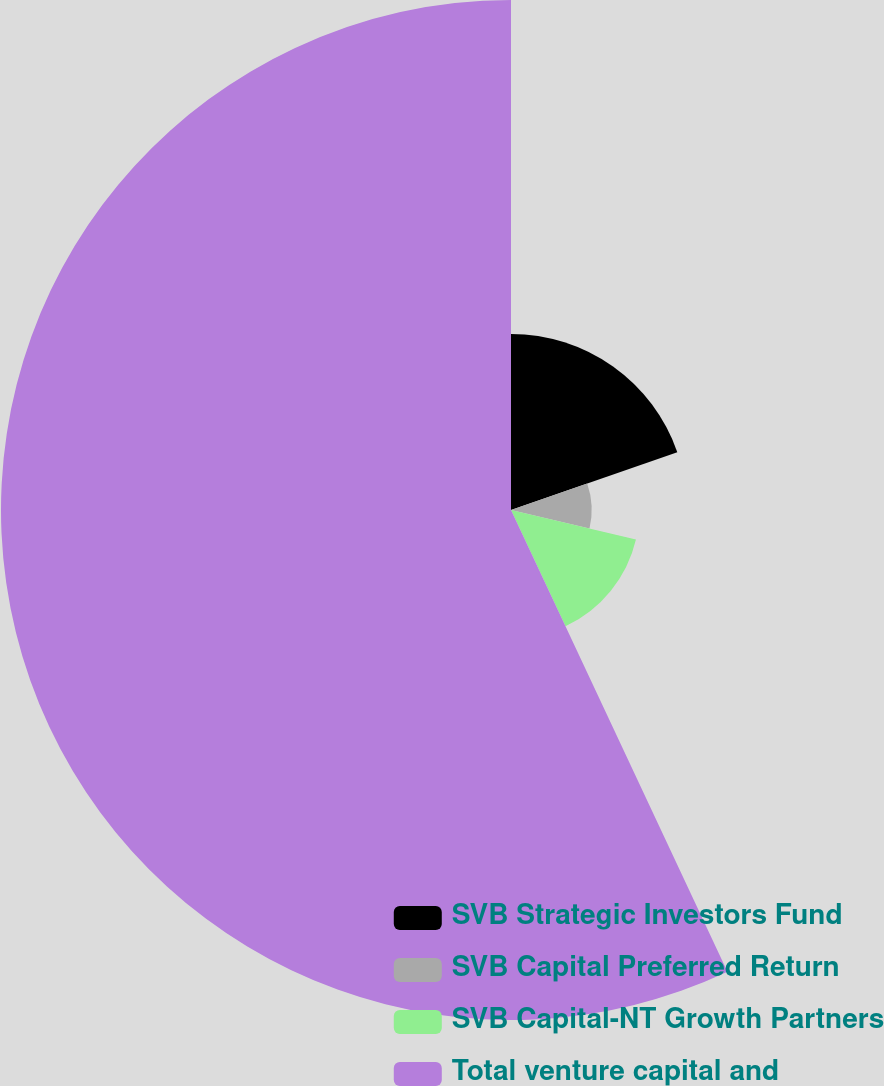Convert chart to OTSL. <chart><loc_0><loc_0><loc_500><loc_500><pie_chart><fcel>SVB Strategic Investors Fund<fcel>SVB Capital Preferred Return<fcel>SVB Capital-NT Growth Partners<fcel>Total venture capital and<nl><fcel>19.67%<fcel>9.01%<fcel>14.34%<fcel>56.97%<nl></chart> 